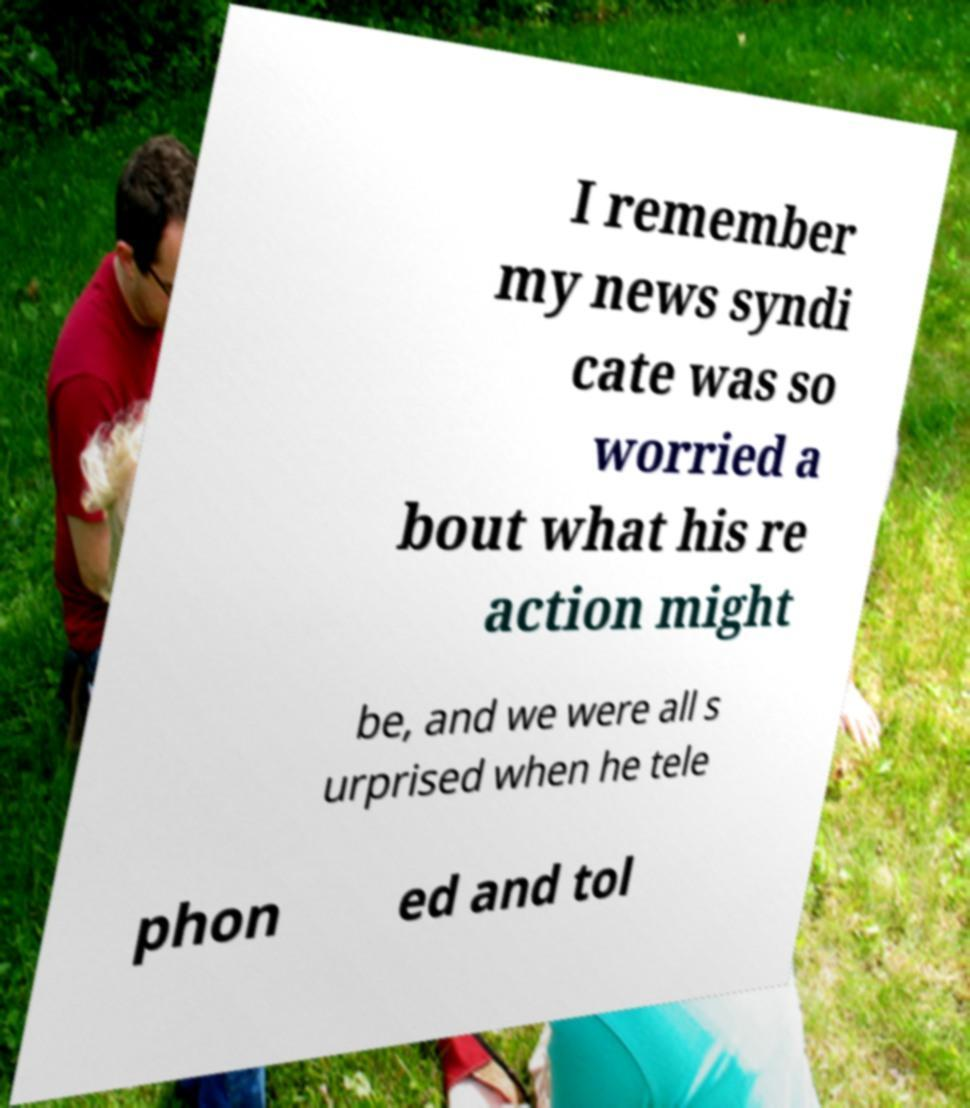Could you extract and type out the text from this image? I remember my news syndi cate was so worried a bout what his re action might be, and we were all s urprised when he tele phon ed and tol 